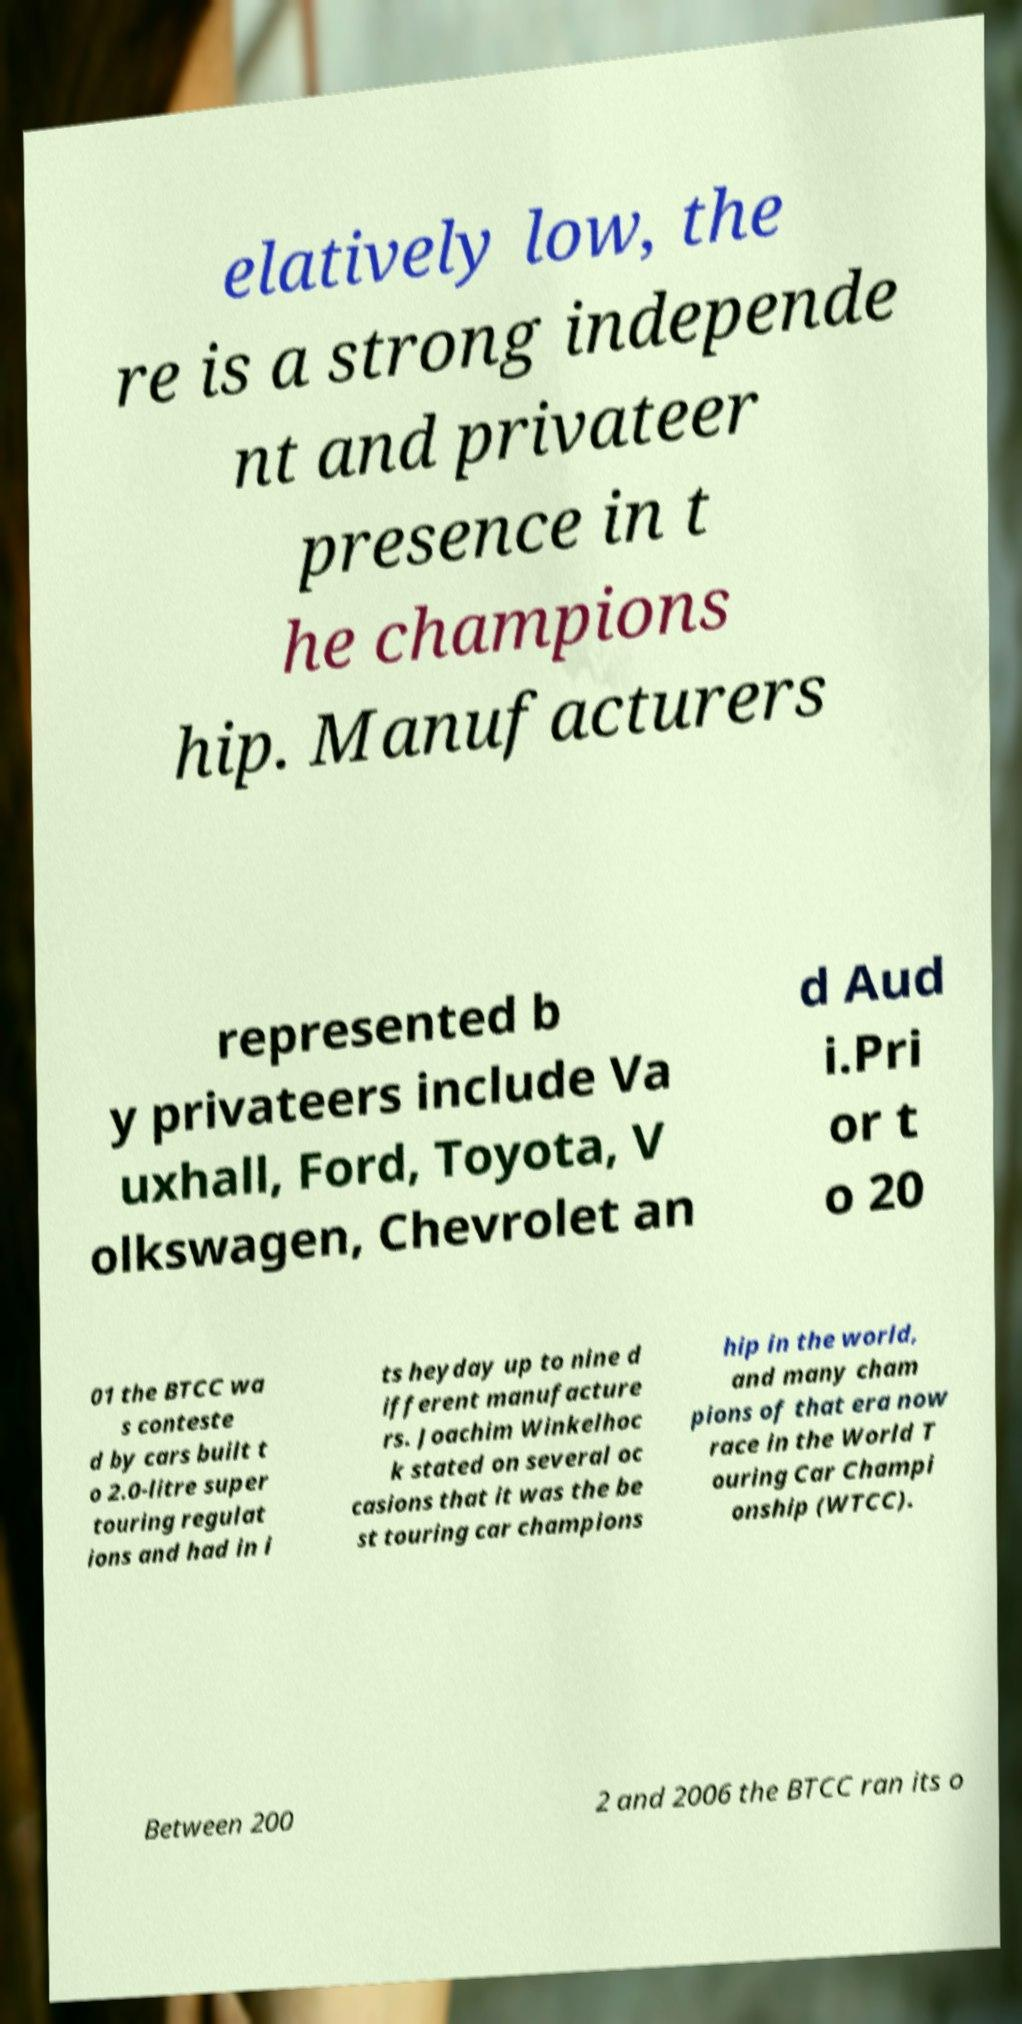For documentation purposes, I need the text within this image transcribed. Could you provide that? elatively low, the re is a strong independe nt and privateer presence in t he champions hip. Manufacturers represented b y privateers include Va uxhall, Ford, Toyota, V olkswagen, Chevrolet an d Aud i.Pri or t o 20 01 the BTCC wa s conteste d by cars built t o 2.0-litre super touring regulat ions and had in i ts heyday up to nine d ifferent manufacture rs. Joachim Winkelhoc k stated on several oc casions that it was the be st touring car champions hip in the world, and many cham pions of that era now race in the World T ouring Car Champi onship (WTCC). Between 200 2 and 2006 the BTCC ran its o 